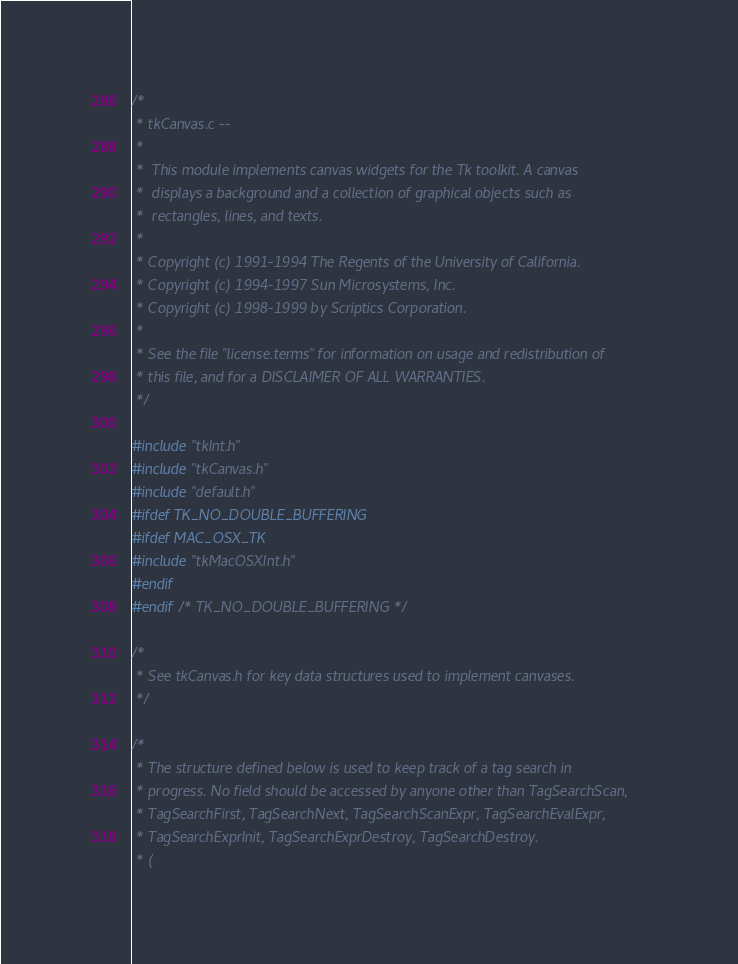Convert code to text. <code><loc_0><loc_0><loc_500><loc_500><_C_>/*
 * tkCanvas.c --
 *
 *	This module implements canvas widgets for the Tk toolkit. A canvas
 *	displays a background and a collection of graphical objects such as
 *	rectangles, lines, and texts.
 *
 * Copyright (c) 1991-1994 The Regents of the University of California.
 * Copyright (c) 1994-1997 Sun Microsystems, Inc.
 * Copyright (c) 1998-1999 by Scriptics Corporation.
 *
 * See the file "license.terms" for information on usage and redistribution of
 * this file, and for a DISCLAIMER OF ALL WARRANTIES.
 */

#include "tkInt.h"
#include "tkCanvas.h"
#include "default.h"
#ifdef TK_NO_DOUBLE_BUFFERING
#ifdef MAC_OSX_TK
#include "tkMacOSXInt.h"
#endif
#endif /* TK_NO_DOUBLE_BUFFERING */

/*
 * See tkCanvas.h for key data structures used to implement canvases.
 */

/*
 * The structure defined below is used to keep track of a tag search in
 * progress. No field should be accessed by anyone other than TagSearchScan,
 * TagSearchFirst, TagSearchNext, TagSearchScanExpr, TagSearchEvalExpr,
 * TagSearchExprInit, TagSearchExprDestroy, TagSearchDestroy.
 * (</code> 